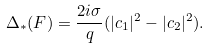<formula> <loc_0><loc_0><loc_500><loc_500>\Delta _ { \ast } ( F ) = \frac { 2 i \sigma } { q } ( | c _ { 1 } | ^ { 2 } - | c _ { 2 } | ^ { 2 } ) .</formula> 